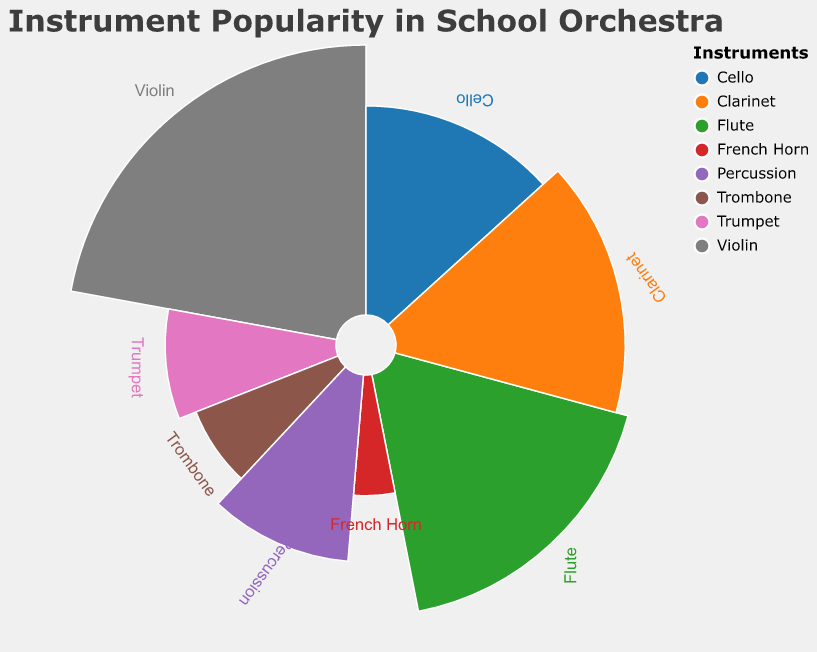What is the title of the figure? The title is displayed at the top of the figure, describing its main topic. It reads "Instrument Popularity in School Orchestra."
Answer: Instrument Popularity in School Orchestra Which instrument has the highest popularity? By visually identifying the slice with the largest arc, you can see that the Violin has the highest popularity.
Answer: Violin How many instruments are represented in the figure? By counting the distinct slices or legend entries, you will note there are eight different instruments.
Answer: 8 Which instrument has more popularity, Flute or Clarinet? To compare the two slices visually, determine which slice extends farther around the circle. The Flute slice is larger than the Clarinet slice.
Answer: Flute What is the combined popularity of the Trumpet and Trombone? By summing the popularity values of Trumpet and Trombone (10 + 8), you get the total.
Answer: 18 Rank the instruments from most popular to least popular. By ordering the slices or values from largest to smallest, you get the following order: Violin, Flute, Clarinet, Cello, Percussion, Trumpet, Trombone, French Horn.
Answer: Violin, Flute, Clarinet, Cello, Percussion, Trumpet, Trombone, French Horn Is the popularity of the Percussion section greater than the Trombone and French Horn combined? Compare the sum of Trombone and French Horn (8 + 5 = 13) to the value of Percussion (12). Percussion's popularity is less.
Answer: No Which instrument has the smallest slice in the chart? By identifying the smallest arc, you can see that the French Horn has the smallest slice.
Answer: French Horn What is the percentage popularity of the Cello? Calculate the percentage by dividing the Cello's popularity (15) by the total popularity (25 + 15 + 20 + 18 + 10 + 8 + 5 + 12 = 113), then multiply by 100. (15/113)*100 ≈ 13.27%.
Answer: 13.27% How much more popular is the Clarinet compared to the Trumpet? Subtract the Trumpet's popularity from the Clarinet's popularity (18 - 10). The Clarinet is 8 more popular than the Trumpet.
Answer: 8 